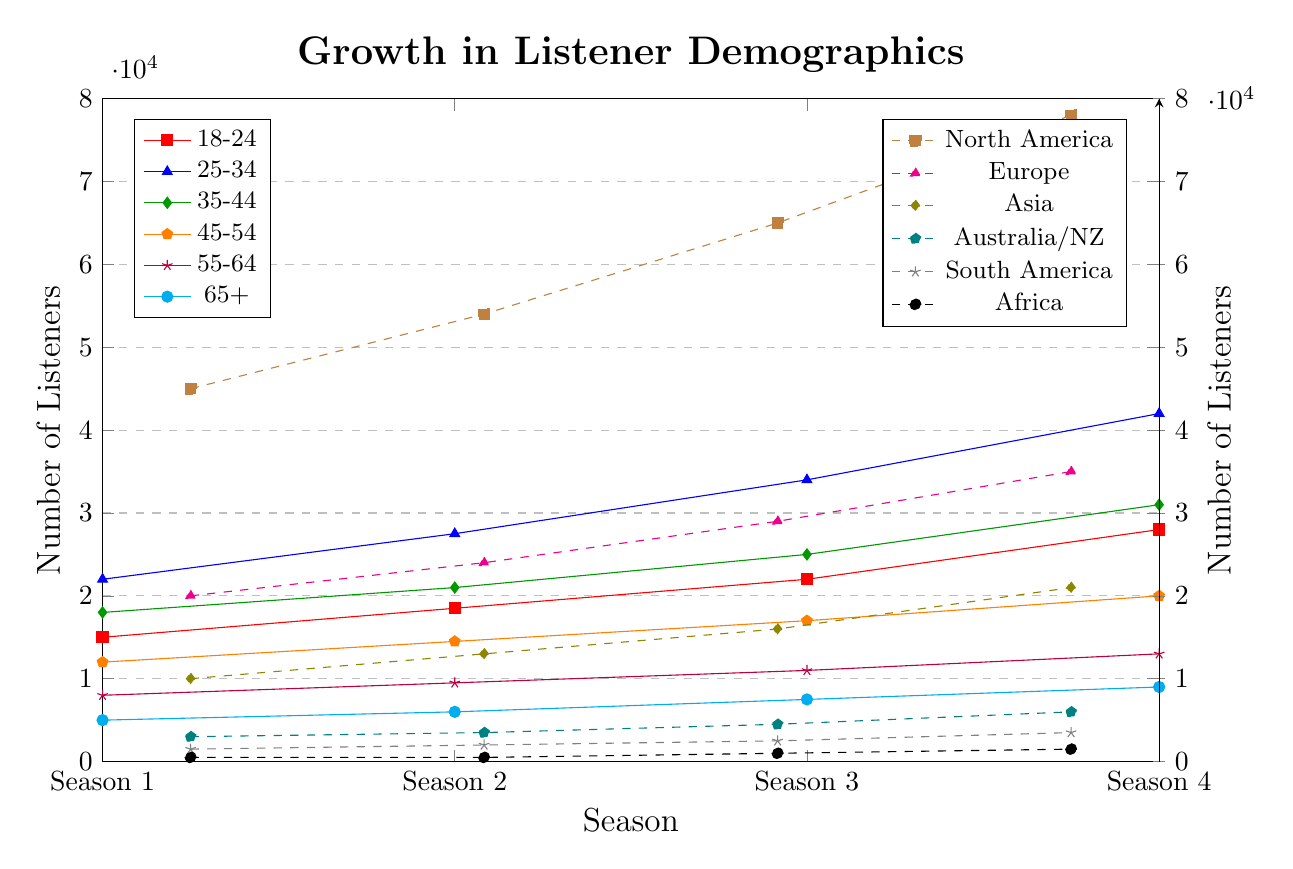Which age group shows the highest increase in the number of listeners between Season 1 and Season 4? The age group 25-34 starts with 22,000 listeners in Season 1 and rises to 42,000 in Season 4. The increase is 42,000 - 22,000 = 20,000, which is the highest increase among all age groups.
Answer: 25-34 Which geographic region demonstrates the smallest growth in listeners from Season 1 to Season 4? Africa starts with 500 listeners in Season 1 and has 1,500 in Season 4, resulting in an increase of 1,000 listeners. This growth is the smallest among all the listed regions.
Answer: Africa Between Seasons 2 and 3, which age group experienced the greatest percentage growth? For the 18-24 age group, growth from 18,500 to 22,000 represents (22,000 - 18,500)/18,500 ≈ 0.189 or 18.9%. Calculating similarly for other groups, no other group has a higher percentage.
Answer: 18-24 Comparing Season 3 numbers, which is greater: the number of listeners in Asia or the number of listeners aged 45-54? In Season 3, Asia has 16,000 listeners while the age group 45-54 has 17,000 listeners.
Answer: 45-54 age group Which age group has the lowest total number of listeners summed across all seasons? Summing across all seasons: 65+ group has 5,000 + 6,000 + 7,500 + 9,000 = 27,500, which is the lowest.
Answer: 65+ What is the average number of listeners for the 35-44 age group across all seasons? Total for 35-44 age group: 18,000 + 21,000 + 25,000 + 31,000 = 95,000. Average: 95,000/4 = 23,750.
Answer: 23,750 Between Seasons 1 and 2, which geographic region shows a stagnation in the number of listeners? Africa remains the same with 500 listeners in Seasons 1 and 2.
Answer: Africa By how much did the number of listeners in Europe increase from Season 1 to Season 4? Europe saw an increase from 20,000 to 35,000: 35,000 - 20,000 = 15,000.
Answer: 15,000 